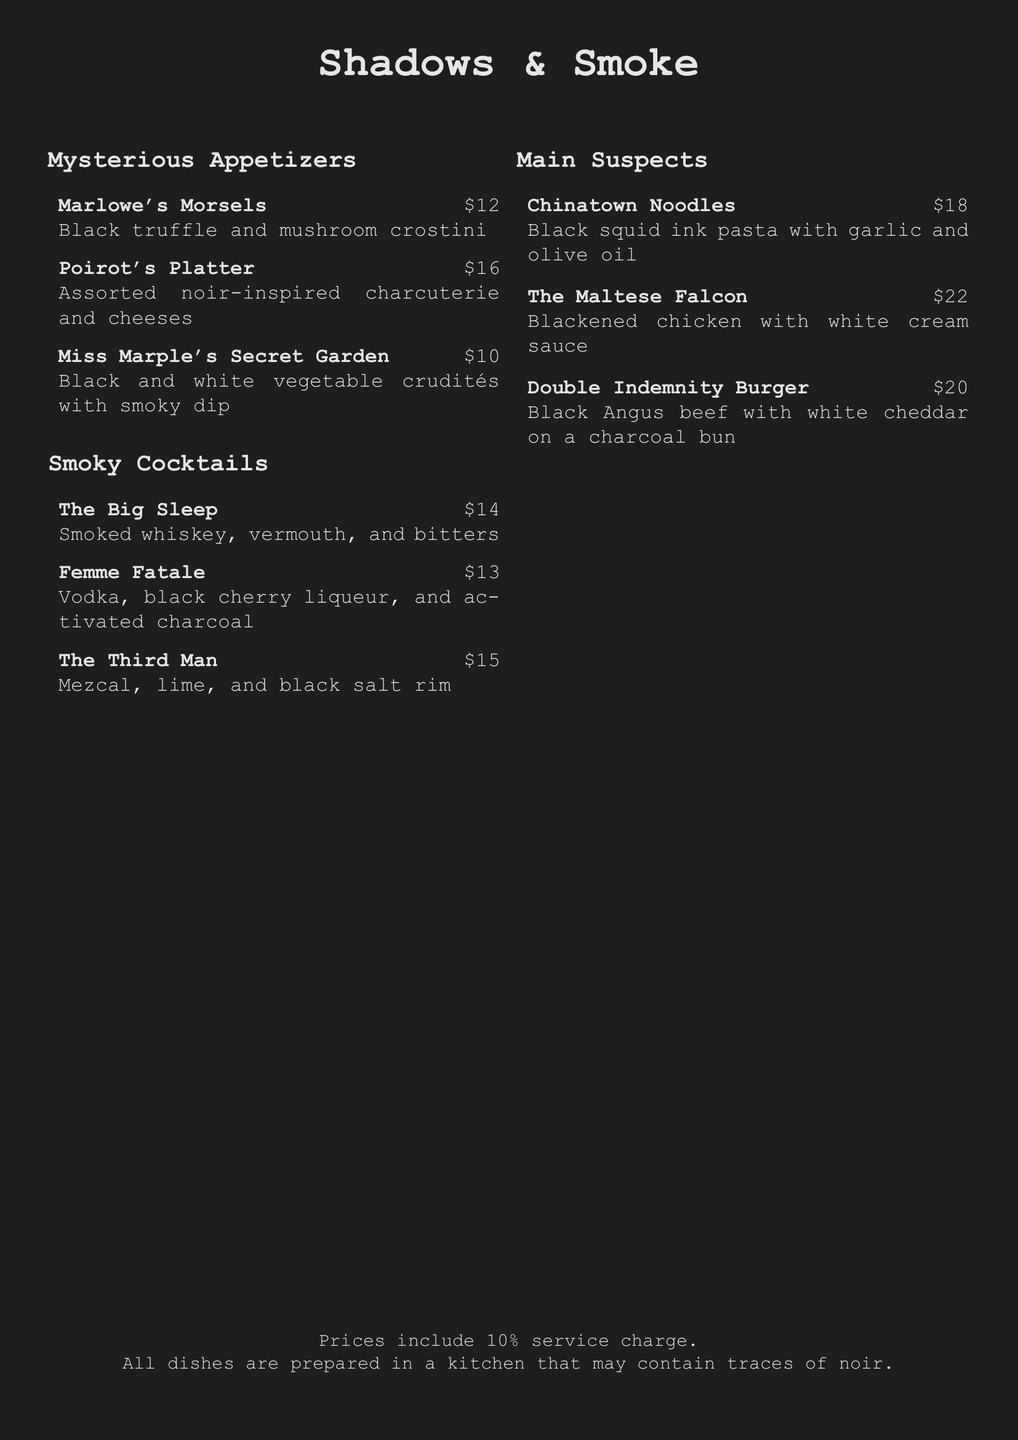What is the name of the restaurant? The name of the restaurant is prominently displayed at the top of the menu.
Answer: Shadows & Smoke How much do Marlowe's Morsels cost? The price for Marlowe's Morsels is listed next to the item on the menu.
Answer: $12 What are the ingredients in The Big Sleep cocktail? The ingredients for The Big Sleep are listed directly under the cocktail name.
Answer: Smoked whiskey, vermouth, and bitters Which appetizer costs the least? By comparing the prices of the appetizers, we can identify the least expensive one.
Answer: Miss Marple's Secret Garden How many cocktails are listed on the menu? The number of cocktails can be counted from the menu section dedicated to them.
Answer: 3 What is the price of The Maltese Falcon? The price is clearly indicated next to the dish in the main suspects section.
Answer: $22 What type of pasta is used in Chinatown Noodles? The type of pasta is specified in the description of Chinatown Noodles.
Answer: Black squid ink pasta Which detective is associated with the platter? The platter is linked to a famous detective mentioned in its name.
Answer: Poirot What additional flavoring does Femme Fatale contain? The unique ingredient is detailed in the cocktail description.
Answer: Activated charcoal 